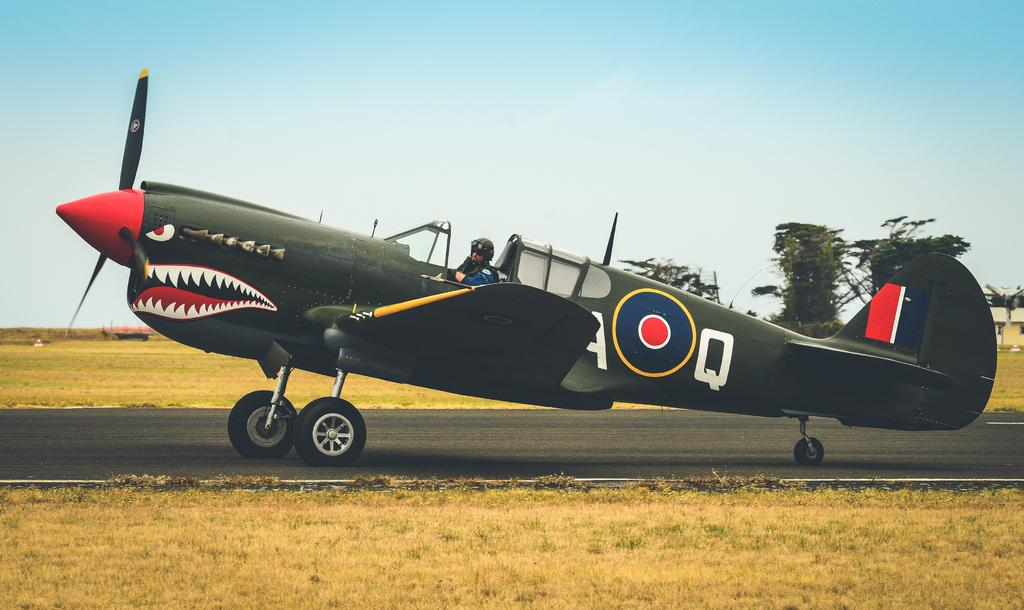What is the main subject of the image? The main subject of the image is an airplane on the ground. Can you describe the person in the image? The person in the image is wearing a helmet. What can be seen in the background of the image? There is an object, a building, trees, grass, and the sky visible in the background of the image. What type of bun is being used to secure the person's helmet in the image? There is no bun visible in the image; the person is wearing a helmet, but there is no indication of how it is secured. What type of operation is being performed on the airplane in the image? There is no operation being performed on the airplane in the image; it is simply on the ground. 